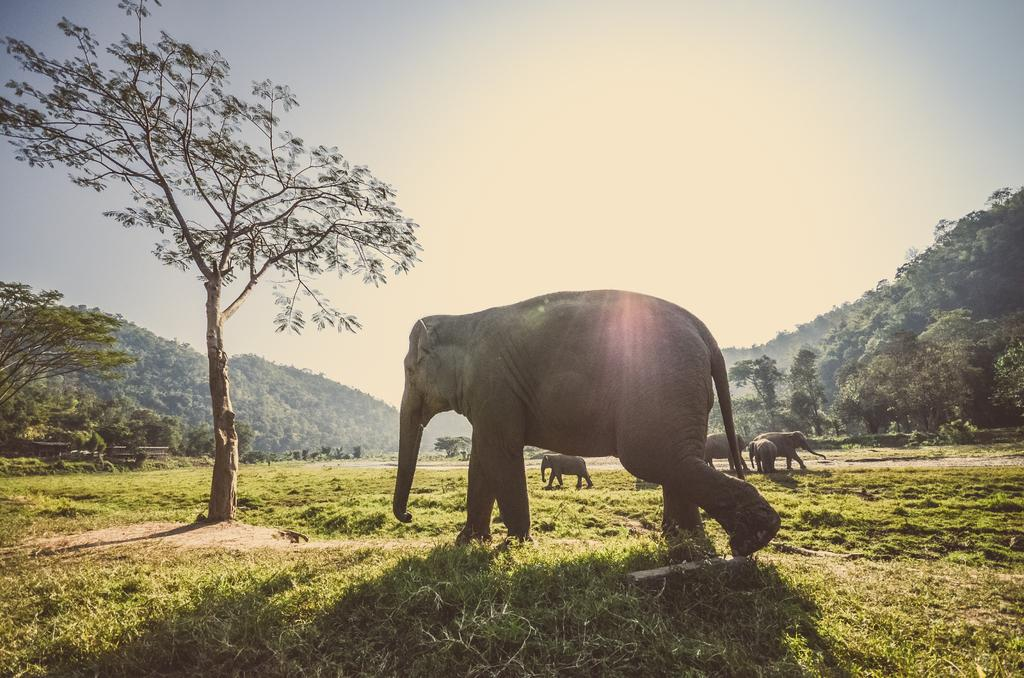What animals are present in the image? There is a group of elephants in the image. What are the elephants doing in the image? The elephants are walking on the ground. What type of vegetation can be seen in the image? Grass and trees are visible in the image. What can be seen in the background of the image? Mountains and the sky are present in the background of the image. What type of card is being used by the elephants in the image? There is no card present in the image; it features a group of elephants walking on the ground. What is the condition of the bed in the image? There is no bed present in the image; it features a group of elephants walking on the ground. 